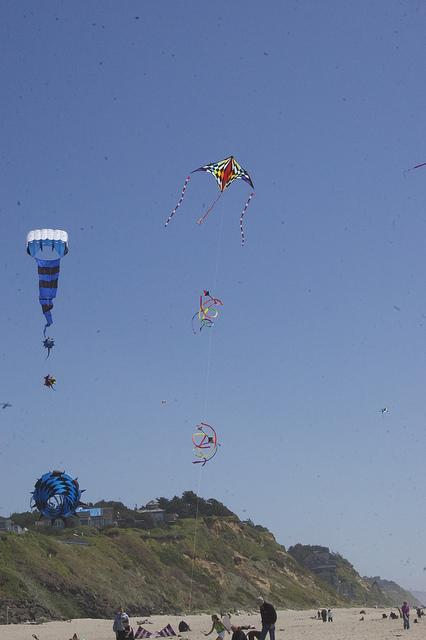What natural disaster are those houses likely safe from? tsunami 